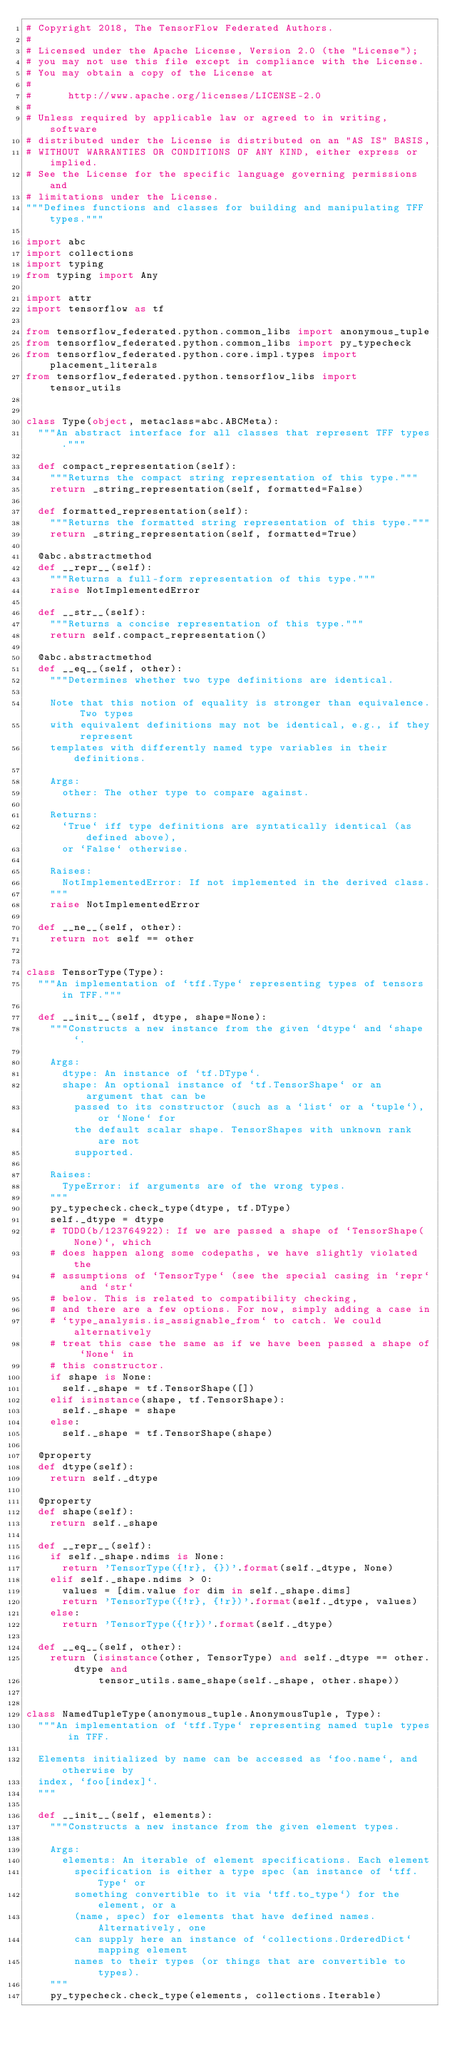Convert code to text. <code><loc_0><loc_0><loc_500><loc_500><_Python_># Copyright 2018, The TensorFlow Federated Authors.
#
# Licensed under the Apache License, Version 2.0 (the "License");
# you may not use this file except in compliance with the License.
# You may obtain a copy of the License at
#
#      http://www.apache.org/licenses/LICENSE-2.0
#
# Unless required by applicable law or agreed to in writing, software
# distributed under the License is distributed on an "AS IS" BASIS,
# WITHOUT WARRANTIES OR CONDITIONS OF ANY KIND, either express or implied.
# See the License for the specific language governing permissions and
# limitations under the License.
"""Defines functions and classes for building and manipulating TFF types."""

import abc
import collections
import typing
from typing import Any

import attr
import tensorflow as tf

from tensorflow_federated.python.common_libs import anonymous_tuple
from tensorflow_federated.python.common_libs import py_typecheck
from tensorflow_federated.python.core.impl.types import placement_literals
from tensorflow_federated.python.tensorflow_libs import tensor_utils


class Type(object, metaclass=abc.ABCMeta):
  """An abstract interface for all classes that represent TFF types."""

  def compact_representation(self):
    """Returns the compact string representation of this type."""
    return _string_representation(self, formatted=False)

  def formatted_representation(self):
    """Returns the formatted string representation of this type."""
    return _string_representation(self, formatted=True)

  @abc.abstractmethod
  def __repr__(self):
    """Returns a full-form representation of this type."""
    raise NotImplementedError

  def __str__(self):
    """Returns a concise representation of this type."""
    return self.compact_representation()

  @abc.abstractmethod
  def __eq__(self, other):
    """Determines whether two type definitions are identical.

    Note that this notion of equality is stronger than equivalence. Two types
    with equivalent definitions may not be identical, e.g., if they represent
    templates with differently named type variables in their definitions.

    Args:
      other: The other type to compare against.

    Returns:
      `True` iff type definitions are syntatically identical (as defined above),
      or `False` otherwise.

    Raises:
      NotImplementedError: If not implemented in the derived class.
    """
    raise NotImplementedError

  def __ne__(self, other):
    return not self == other


class TensorType(Type):
  """An implementation of `tff.Type` representing types of tensors in TFF."""

  def __init__(self, dtype, shape=None):
    """Constructs a new instance from the given `dtype` and `shape`.

    Args:
      dtype: An instance of `tf.DType`.
      shape: An optional instance of `tf.TensorShape` or an argument that can be
        passed to its constructor (such as a `list` or a `tuple`), or `None` for
        the default scalar shape. TensorShapes with unknown rank are not
        supported.

    Raises:
      TypeError: if arguments are of the wrong types.
    """
    py_typecheck.check_type(dtype, tf.DType)
    self._dtype = dtype
    # TODO(b/123764922): If we are passed a shape of `TensorShape(None)`, which
    # does happen along some codepaths, we have slightly violated the
    # assumptions of `TensorType` (see the special casing in `repr` and `str`
    # below. This is related to compatibility checking,
    # and there are a few options. For now, simply adding a case in
    # `type_analysis.is_assignable_from` to catch. We could alternatively
    # treat this case the same as if we have been passed a shape of `None` in
    # this constructor.
    if shape is None:
      self._shape = tf.TensorShape([])
    elif isinstance(shape, tf.TensorShape):
      self._shape = shape
    else:
      self._shape = tf.TensorShape(shape)

  @property
  def dtype(self):
    return self._dtype

  @property
  def shape(self):
    return self._shape

  def __repr__(self):
    if self._shape.ndims is None:
      return 'TensorType({!r}, {})'.format(self._dtype, None)
    elif self._shape.ndims > 0:
      values = [dim.value for dim in self._shape.dims]
      return 'TensorType({!r}, {!r})'.format(self._dtype, values)
    else:
      return 'TensorType({!r})'.format(self._dtype)

  def __eq__(self, other):
    return (isinstance(other, TensorType) and self._dtype == other.dtype and
            tensor_utils.same_shape(self._shape, other.shape))


class NamedTupleType(anonymous_tuple.AnonymousTuple, Type):
  """An implementation of `tff.Type` representing named tuple types in TFF.

  Elements initialized by name can be accessed as `foo.name`, and otherwise by
  index, `foo[index]`.
  """

  def __init__(self, elements):
    """Constructs a new instance from the given element types.

    Args:
      elements: An iterable of element specifications. Each element
        specification is either a type spec (an instance of `tff.Type` or
        something convertible to it via `tff.to_type`) for the element, or a
        (name, spec) for elements that have defined names. Alternatively, one
        can supply here an instance of `collections.OrderedDict` mapping element
        names to their types (or things that are convertible to types).
    """
    py_typecheck.check_type(elements, collections.Iterable)</code> 